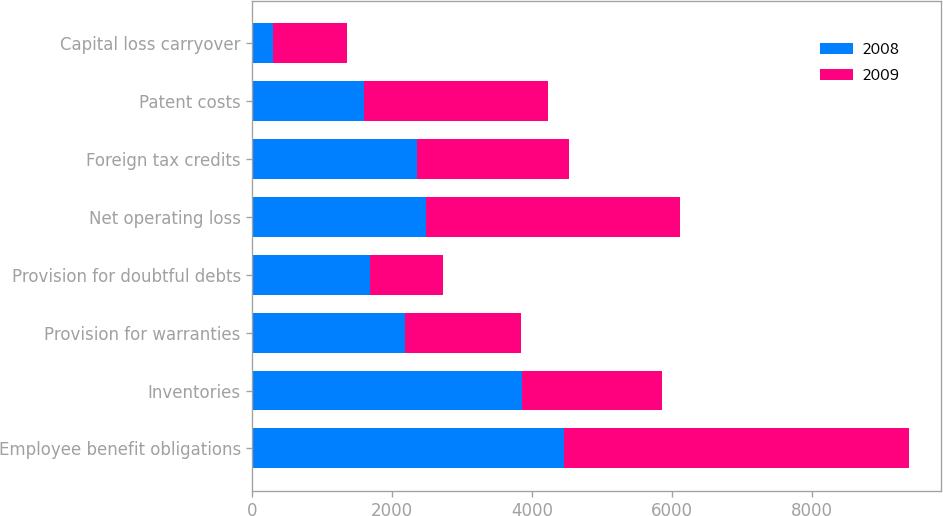<chart> <loc_0><loc_0><loc_500><loc_500><stacked_bar_chart><ecel><fcel>Employee benefit obligations<fcel>Inventories<fcel>Provision for warranties<fcel>Provision for doubtful debts<fcel>Net operating loss<fcel>Foreign tax credits<fcel>Patent costs<fcel>Capital loss carryover<nl><fcel>2008<fcel>4460<fcel>3857<fcel>2181<fcel>1689<fcel>2479<fcel>2355<fcel>1597<fcel>290<nl><fcel>2009<fcel>4930<fcel>2003<fcel>1658<fcel>1041<fcel>3632<fcel>2181<fcel>2626<fcel>1061<nl></chart> 